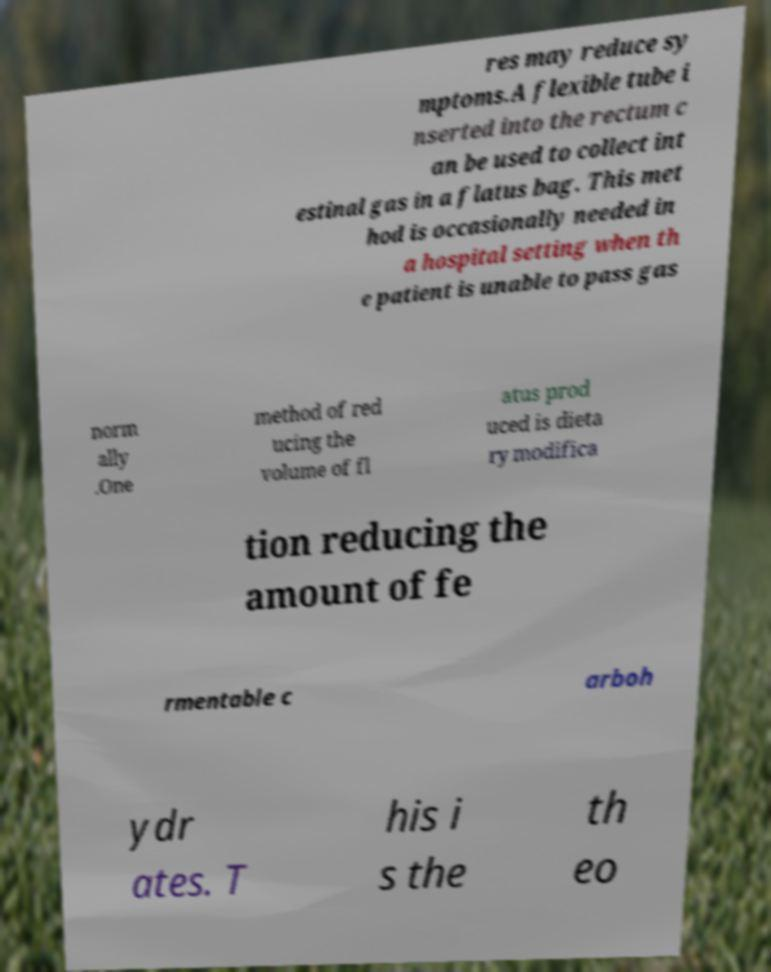Please read and relay the text visible in this image. What does it say? res may reduce sy mptoms.A flexible tube i nserted into the rectum c an be used to collect int estinal gas in a flatus bag. This met hod is occasionally needed in a hospital setting when th e patient is unable to pass gas norm ally .One method of red ucing the volume of fl atus prod uced is dieta ry modifica tion reducing the amount of fe rmentable c arboh ydr ates. T his i s the th eo 